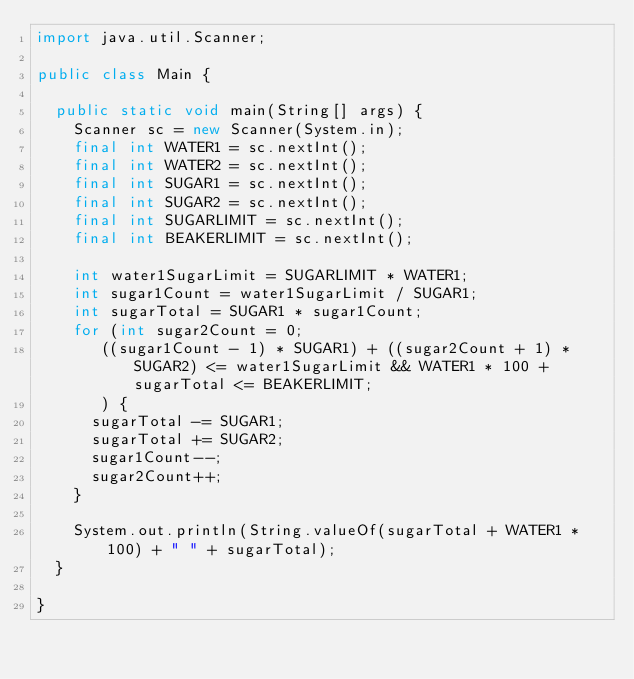Convert code to text. <code><loc_0><loc_0><loc_500><loc_500><_Java_>import java.util.Scanner;

public class Main {

	public static void main(String[] args) {
		Scanner sc = new Scanner(System.in);
		final int WATER1 = sc.nextInt();
		final int WATER2 = sc.nextInt();
		final int SUGAR1 = sc.nextInt();
		final int SUGAR2 = sc.nextInt();
		final int SUGARLIMIT = sc.nextInt();
		final int BEAKERLIMIT = sc.nextInt();

		int water1SugarLimit = SUGARLIMIT * WATER1;
		int sugar1Count = water1SugarLimit / SUGAR1;
		int sugarTotal = SUGAR1 * sugar1Count;
		for (int sugar2Count = 0;
			 ((sugar1Count - 1) * SUGAR1) + ((sugar2Count + 1) * SUGAR2) <= water1SugarLimit && WATER1 * 100 + sugarTotal <= BEAKERLIMIT;
			 ) {
			sugarTotal -= SUGAR1;
			sugarTotal += SUGAR2;
			sugar1Count--;
			sugar2Count++;
		}

		System.out.println(String.valueOf(sugarTotal + WATER1 * 100) + " " + sugarTotal);
	}

}
</code> 